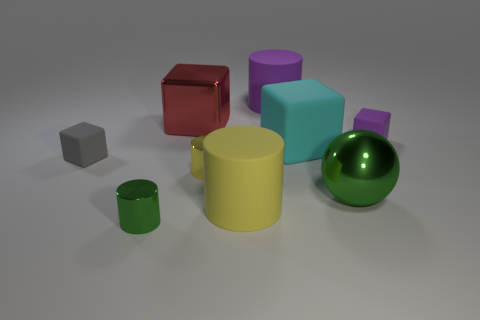Subtract all balls. How many objects are left? 8 Add 3 balls. How many balls are left? 4 Add 6 small red shiny cylinders. How many small red shiny cylinders exist? 6 Subtract 0 gray cylinders. How many objects are left? 9 Subtract all large green metal spheres. Subtract all big cyan blocks. How many objects are left? 7 